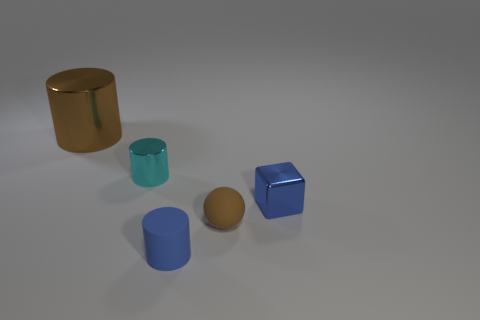There is another tiny object that is the same material as the small brown object; what is its shape?
Provide a short and direct response. Cylinder. What number of small gray spheres are there?
Make the answer very short. 0. How many things are tiny objects to the right of the blue matte object or big gray rubber cylinders?
Provide a succinct answer. 2. Does the object on the right side of the small brown rubber thing have the same color as the big metallic cylinder?
Offer a terse response. No. What number of other things are there of the same color as the small shiny cylinder?
Offer a very short reply. 0. How many big things are blue metallic blocks or metallic objects?
Your answer should be compact. 1. Are there more small matte balls than tiny objects?
Keep it short and to the point. No. Is the small cyan cylinder made of the same material as the sphere?
Provide a succinct answer. No. Are there more tiny cylinders behind the tiny blue rubber cylinder than purple rubber cubes?
Give a very brief answer. Yes. Is the color of the ball the same as the large metallic object?
Provide a short and direct response. Yes. 